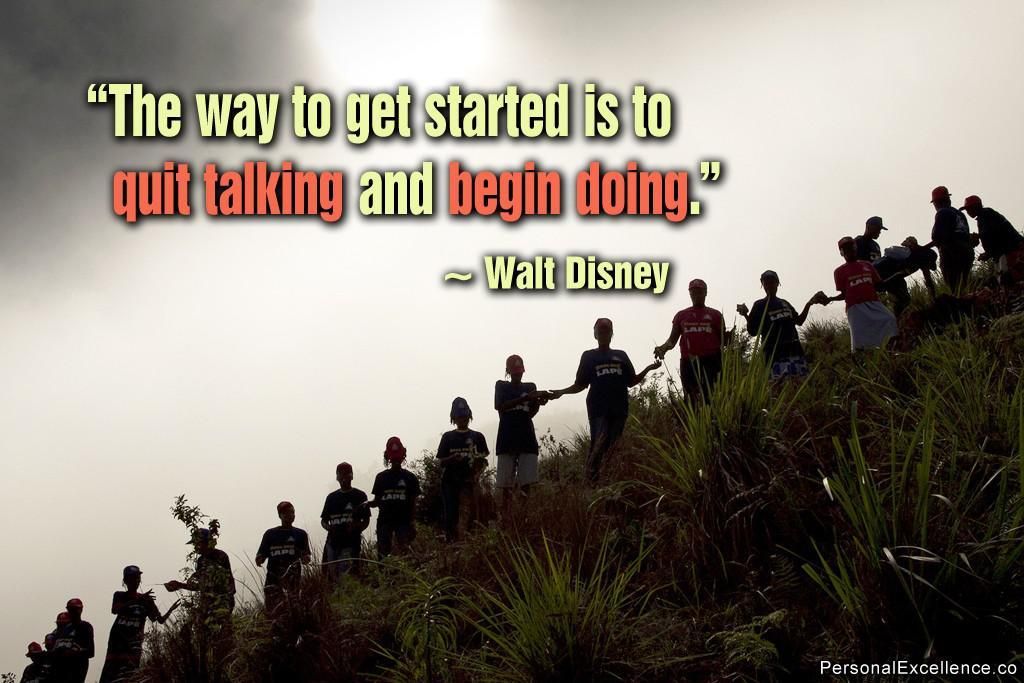<image>
Provide a brief description of the given image. A quote on a picture that reads "The way to get started is to quit talking and being doing." 